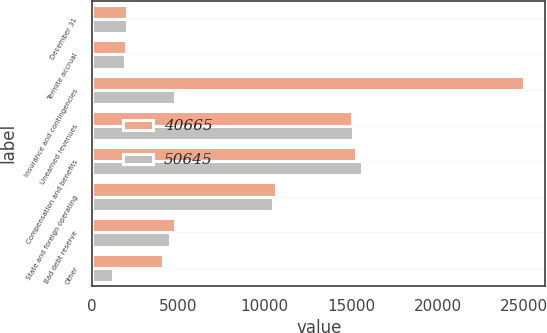<chart> <loc_0><loc_0><loc_500><loc_500><stacked_bar_chart><ecel><fcel>December 31<fcel>Termite accrual<fcel>Insurance and contingencies<fcel>Unearned revenues<fcel>Compensation and benefits<fcel>State and foreign operating<fcel>Bad debt reserve<fcel>Other<nl><fcel>40665<fcel>2015<fcel>1968<fcel>24991<fcel>15026<fcel>15288<fcel>10629<fcel>4779<fcel>4133<nl><fcel>50645<fcel>2014<fcel>1887<fcel>4779<fcel>15086<fcel>15641<fcel>10454<fcel>4520<fcel>1217<nl></chart> 